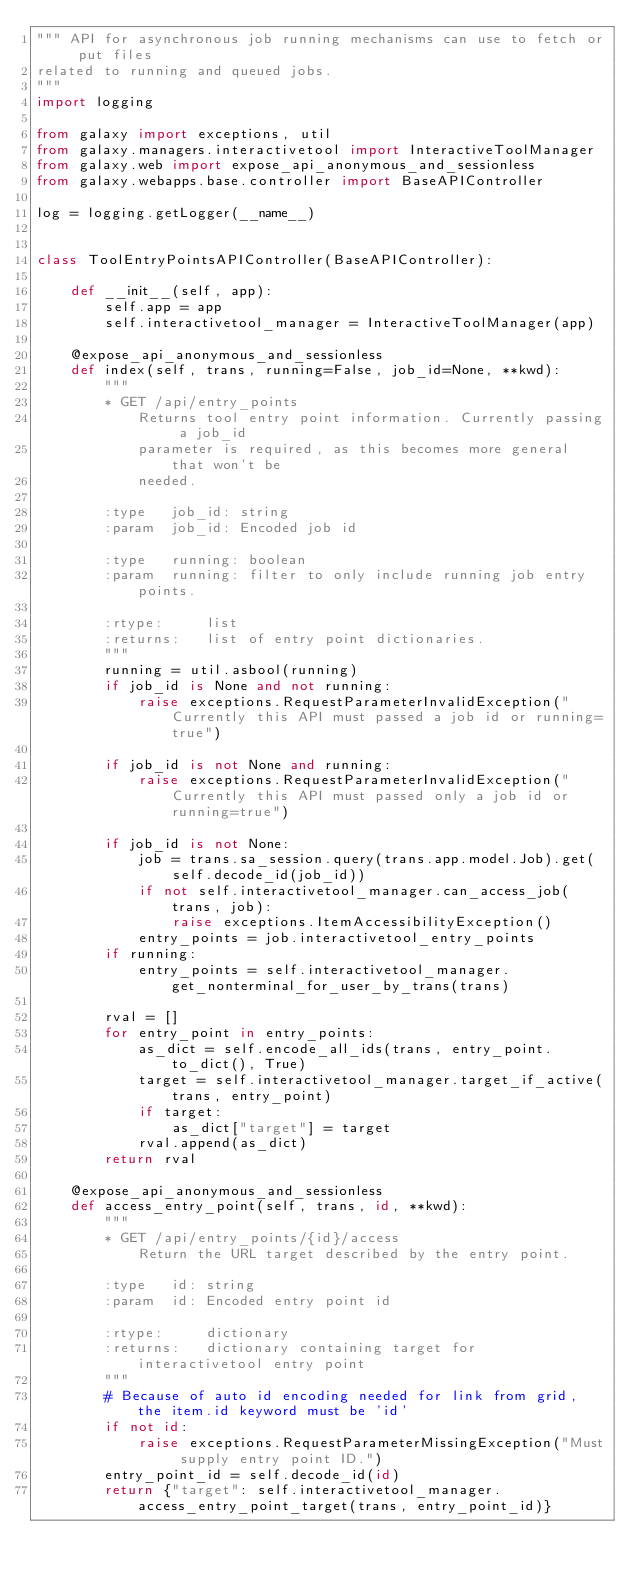Convert code to text. <code><loc_0><loc_0><loc_500><loc_500><_Python_>""" API for asynchronous job running mechanisms can use to fetch or put files
related to running and queued jobs.
"""
import logging

from galaxy import exceptions, util
from galaxy.managers.interactivetool import InteractiveToolManager
from galaxy.web import expose_api_anonymous_and_sessionless
from galaxy.webapps.base.controller import BaseAPIController

log = logging.getLogger(__name__)


class ToolEntryPointsAPIController(BaseAPIController):

    def __init__(self, app):
        self.app = app
        self.interactivetool_manager = InteractiveToolManager(app)

    @expose_api_anonymous_and_sessionless
    def index(self, trans, running=False, job_id=None, **kwd):
        """
        * GET /api/entry_points
            Returns tool entry point information. Currently passing a job_id
            parameter is required, as this becomes more general that won't be
            needed.

        :type   job_id: string
        :param  job_id: Encoded job id

        :type   running: boolean
        :param  running: filter to only include running job entry points.

        :rtype:     list
        :returns:   list of entry point dictionaries.
        """
        running = util.asbool(running)
        if job_id is None and not running:
            raise exceptions.RequestParameterInvalidException("Currently this API must passed a job id or running=true")

        if job_id is not None and running:
            raise exceptions.RequestParameterInvalidException("Currently this API must passed only a job id or running=true")

        if job_id is not None:
            job = trans.sa_session.query(trans.app.model.Job).get(self.decode_id(job_id))
            if not self.interactivetool_manager.can_access_job(trans, job):
                raise exceptions.ItemAccessibilityException()
            entry_points = job.interactivetool_entry_points
        if running:
            entry_points = self.interactivetool_manager.get_nonterminal_for_user_by_trans(trans)

        rval = []
        for entry_point in entry_points:
            as_dict = self.encode_all_ids(trans, entry_point.to_dict(), True)
            target = self.interactivetool_manager.target_if_active(trans, entry_point)
            if target:
                as_dict["target"] = target
            rval.append(as_dict)
        return rval

    @expose_api_anonymous_and_sessionless
    def access_entry_point(self, trans, id, **kwd):
        """
        * GET /api/entry_points/{id}/access
            Return the URL target described by the entry point.

        :type   id: string
        :param  id: Encoded entry point id

        :rtype:     dictionary
        :returns:   dictionary containing target for interactivetool entry point
        """
        # Because of auto id encoding needed for link from grid, the item.id keyword must be 'id'
        if not id:
            raise exceptions.RequestParameterMissingException("Must supply entry point ID.")
        entry_point_id = self.decode_id(id)
        return {"target": self.interactivetool_manager.access_entry_point_target(trans, entry_point_id)}
</code> 